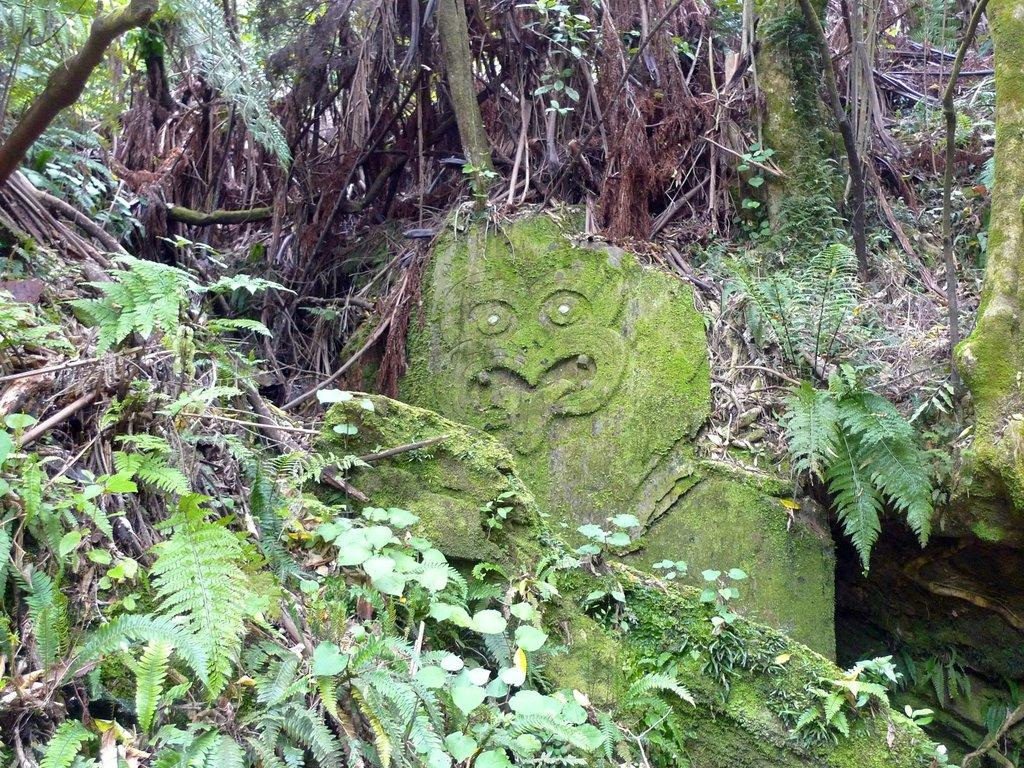What is the main subject in the middle of the image? There is a stone idol in the middle of the image. Where are the plants located in relation to the idol? The plants are on one side of the idol. What is located on the other side of the idol? There are trees on the other side of the idol. Can you see the seashore in the image? There is no reference to a seashore in the image; it features a stone idol with plants and trees on either side. How many giants are visible in the image? There are no giants present in the image. What type of soup is being served in the image? There is no soup present in the image. 